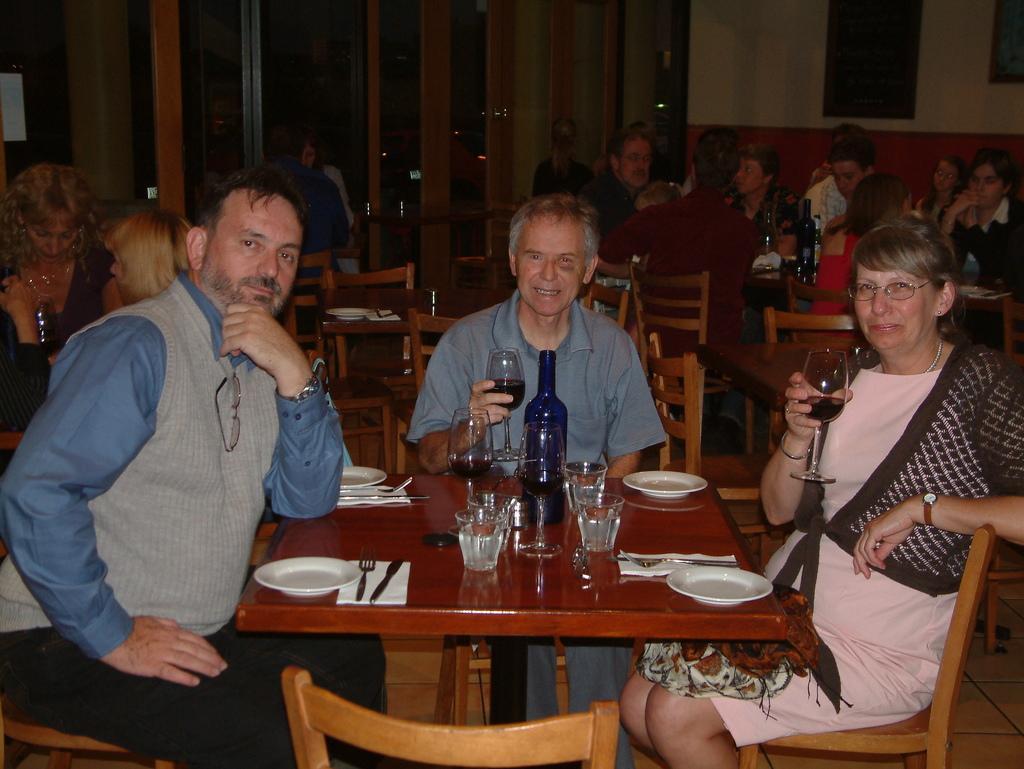Can you describe this image briefly? In this picture we can see two men and one woman sitting on chair and holding glasses with drinks in it with their hands and in front on table we have plate, fork, knife, tissue paper, glasses, bottle and in background we can see some more persons, wall, frame, window. 